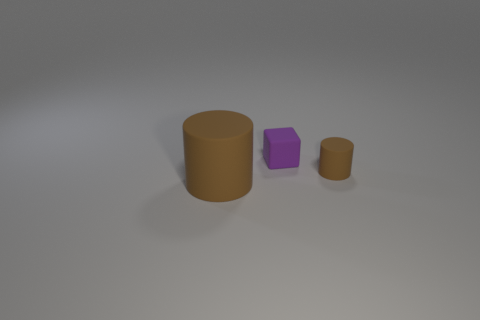Is there anything else that has the same shape as the purple thing?
Your response must be concise. No. Is there anything else that has the same color as the large rubber cylinder?
Make the answer very short. Yes. What shape is the tiny brown thing that is the same material as the big brown object?
Your response must be concise. Cylinder. Is the large object the same color as the tiny matte cylinder?
Your answer should be compact. Yes. Are the thing that is to the left of the purple block and the brown object that is right of the purple block made of the same material?
Your answer should be compact. Yes. What number of objects are small purple rubber things or things in front of the purple matte thing?
Your answer should be compact. 3. Is there anything else that has the same material as the big cylinder?
Your response must be concise. Yes. What shape is the rubber thing that is the same color as the tiny cylinder?
Offer a terse response. Cylinder. What is the large cylinder made of?
Offer a very short reply. Rubber. How many rubber objects are either tiny cubes or tiny brown objects?
Offer a terse response. 2. 